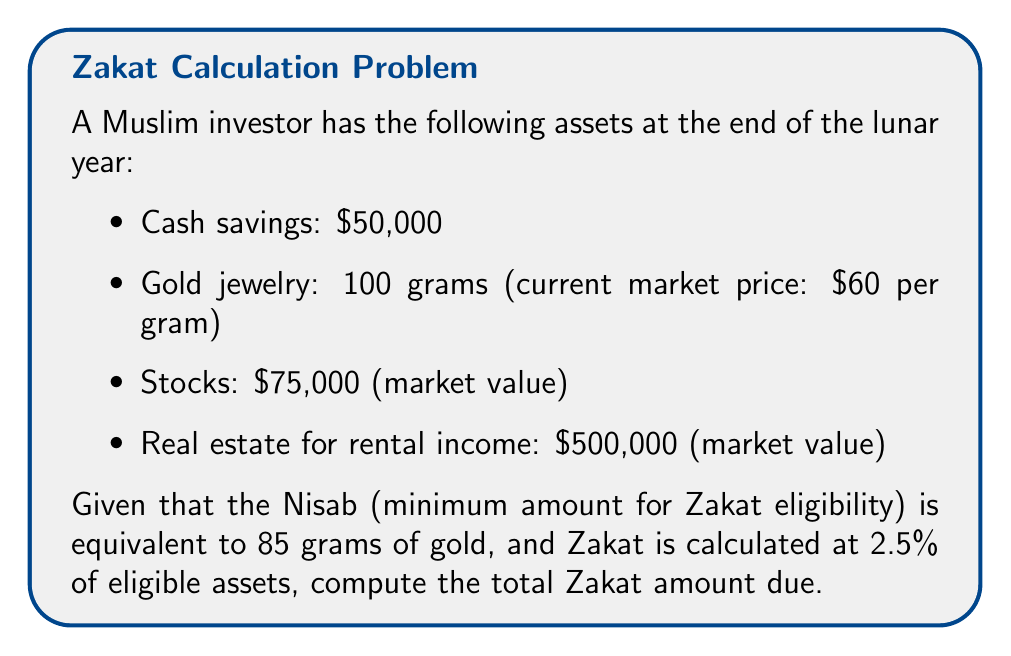Can you answer this question? To solve this problem, we need to follow these steps:

1. Determine which assets are eligible for Zakat:
   - Cash savings: Eligible
   - Gold jewelry: Eligible
   - Stocks: Eligible
   - Real estate for rental income: Not eligible (only rental income is subject to Zakat, not the property value)

2. Calculate the total value of eligible assets:
   $$\text{Total eligible assets} = \text{Cash} + \text{Gold value} + \text{Stocks}$$
   $$\text{Total eligible assets} = \$50,000 + (100 \times \$60) + \$75,000$$
   $$\text{Total eligible assets} = \$50,000 + \$6,000 + \$75,000 = \$131,000$$

3. Check if the total eligible assets exceed the Nisab:
   $$\text{Nisab} = 85 \times \$60 = \$5,100$$
   Since $\$131,000 > \$5,100$, Zakat is due on the entire amount.

4. Calculate the Zakat amount:
   $$\text{Zakat} = \text{Total eligible assets} \times 2.5\%$$
   $$\text{Zakat} = \$131,000 \times 0.025 = \$3,275$$
Answer: The total Zakat amount due is $\$3,275$. 